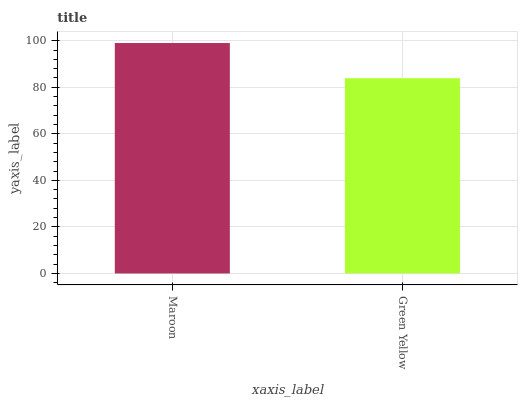Is Green Yellow the minimum?
Answer yes or no. Yes. Is Maroon the maximum?
Answer yes or no. Yes. Is Green Yellow the maximum?
Answer yes or no. No. Is Maroon greater than Green Yellow?
Answer yes or no. Yes. Is Green Yellow less than Maroon?
Answer yes or no. Yes. Is Green Yellow greater than Maroon?
Answer yes or no. No. Is Maroon less than Green Yellow?
Answer yes or no. No. Is Maroon the high median?
Answer yes or no. Yes. Is Green Yellow the low median?
Answer yes or no. Yes. Is Green Yellow the high median?
Answer yes or no. No. Is Maroon the low median?
Answer yes or no. No. 